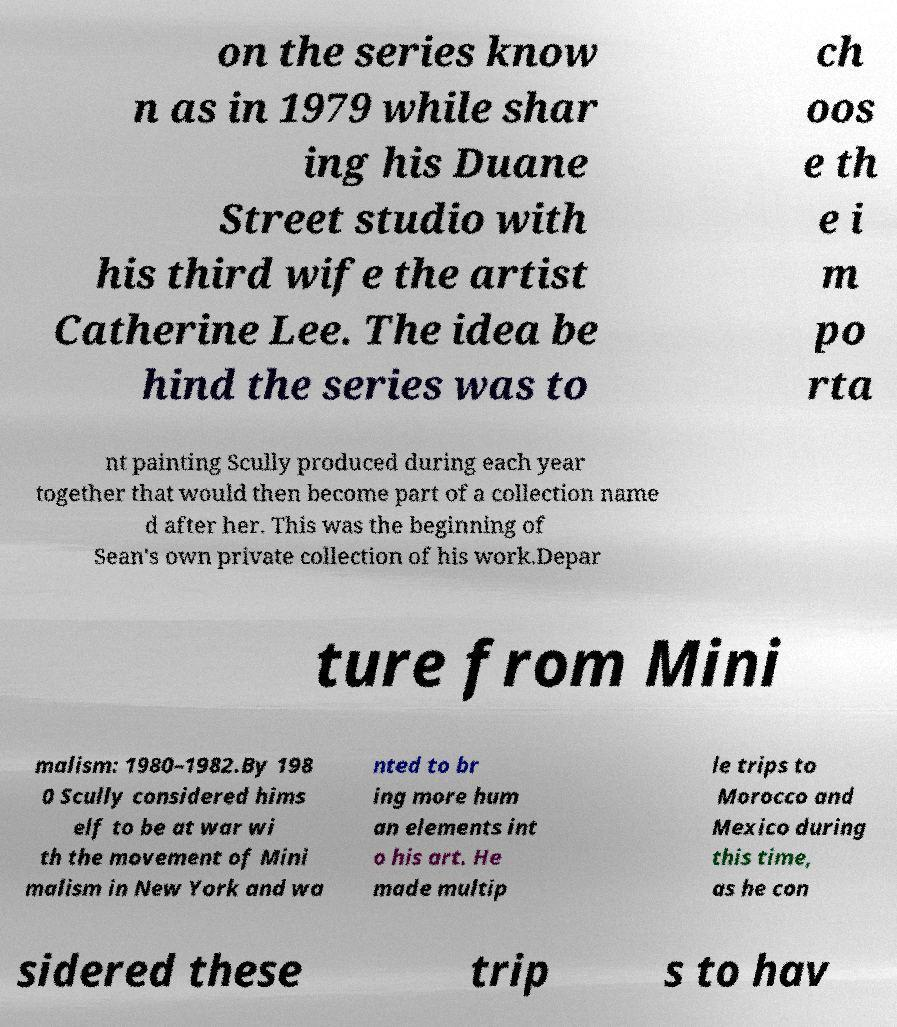Please read and relay the text visible in this image. What does it say? on the series know n as in 1979 while shar ing his Duane Street studio with his third wife the artist Catherine Lee. The idea be hind the series was to ch oos e th e i m po rta nt painting Scully produced during each year together that would then become part of a collection name d after her. This was the beginning of Sean's own private collection of his work.Depar ture from Mini malism: 1980–1982.By 198 0 Scully considered hims elf to be at war wi th the movement of Mini malism in New York and wa nted to br ing more hum an elements int o his art. He made multip le trips to Morocco and Mexico during this time, as he con sidered these trip s to hav 